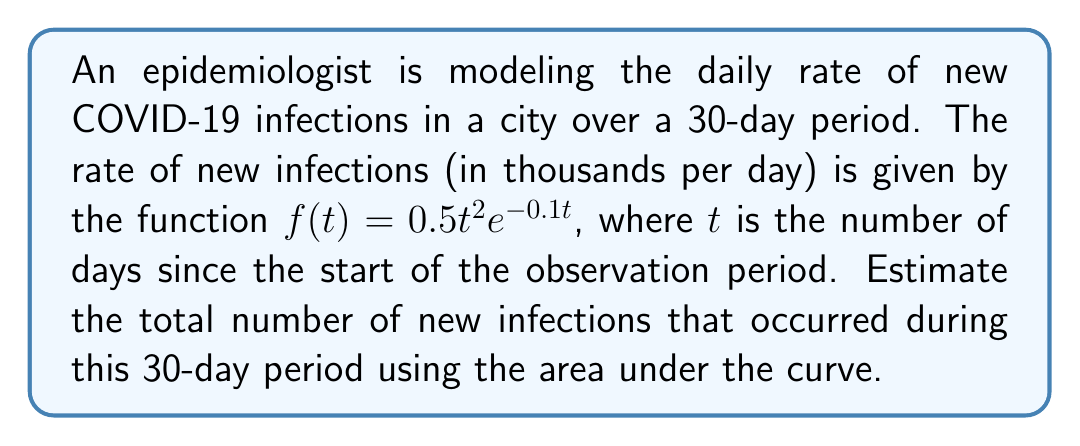Solve this math problem. To estimate the total number of new infections over the 30-day period, we need to calculate the area under the curve of $f(t)$ from $t=0$ to $t=30$. This can be done using a definite integral.

Step 1: Set up the definite integral
$$\int_{0}^{30} f(t) dt = \int_{0}^{30} 0.5t^2e^{-0.1t} dt$$

Step 2: This integral cannot be solved analytically, so we need to use numerical integration. We'll use Simpson's Rule with $n=6$ subintervals for a reasonable approximation.

Simpson's Rule formula:
$$\int_{a}^{b} f(x) dx \approx \frac{h}{3}[f(x_0) + 4f(x_1) + 2f(x_2) + 4f(x_3) + 2f(x_4) + 4f(x_5) + f(x_6)]$$

where $h = \frac{b-a}{n} = \frac{30-0}{6} = 5$

Step 3: Calculate function values at required points:
$f(0) = 0$
$f(5) = 0.5(5^2)e^{-0.5} \approx 3.80$
$f(10) = 0.5(10^2)e^{-1} \approx 13.53$
$f(15) = 0.5(15^2)e^{-1.5} \approx 18.54$
$f(20) = 0.5(20^2)e^{-2} \approx 16.97$
$f(25) = 0.5(25^2)e^{-2.5} \approx 11.64$
$f(30) = 0.5(30^2)e^{-3} \approx 6.72$

Step 4: Apply Simpson's Rule
$$\frac{5}{3}[0 + 4(3.80) + 2(13.53) + 4(18.54) + 2(16.97) + 4(11.64) + 6.72] \approx 404.17$$

Step 5: Interpret the result
The area under the curve represents the total number of new infections in thousands. So, we multiply our result by 1000 to get the actual number of infections.

404.17 * 1000 ≈ 404,170 new infections
Answer: Approximately 404,170 new infections 